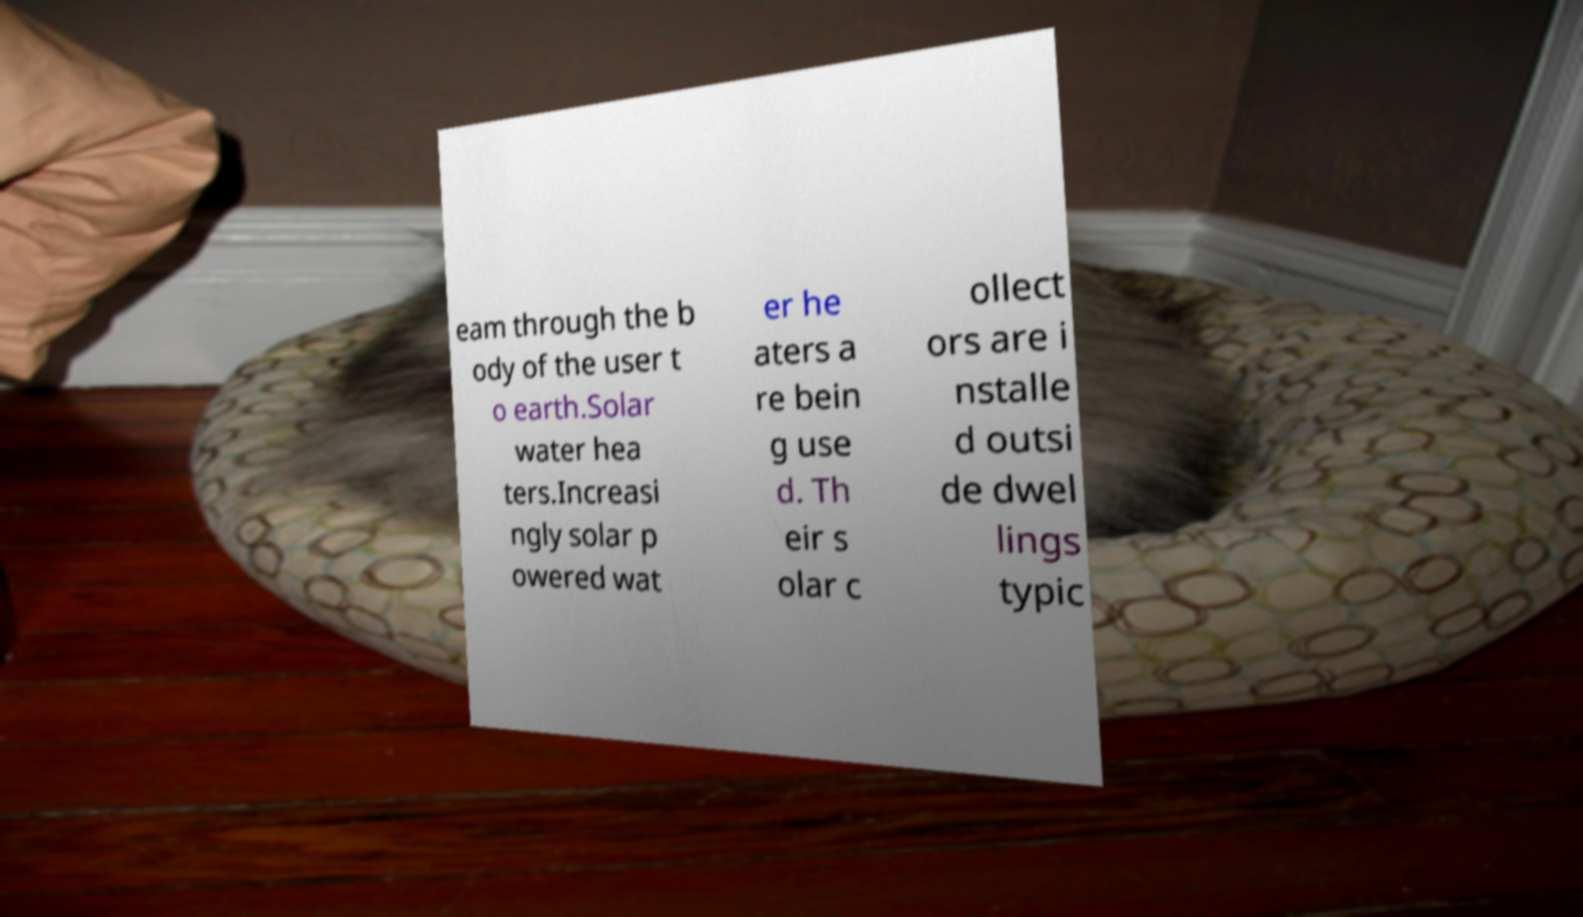Could you assist in decoding the text presented in this image and type it out clearly? eam through the b ody of the user t o earth.Solar water hea ters.Increasi ngly solar p owered wat er he aters a re bein g use d. Th eir s olar c ollect ors are i nstalle d outsi de dwel lings typic 